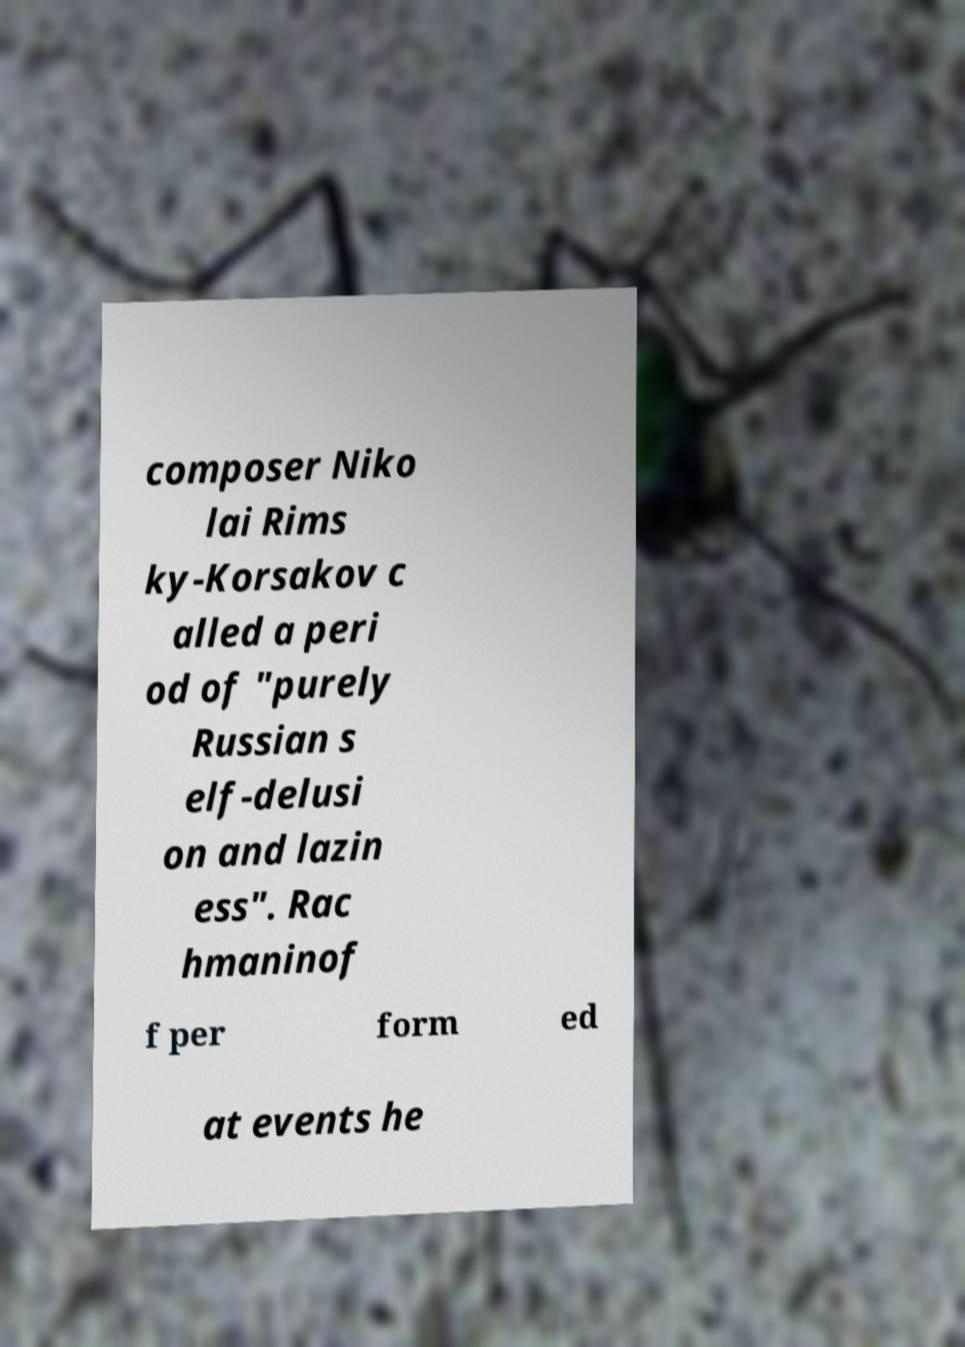For documentation purposes, I need the text within this image transcribed. Could you provide that? composer Niko lai Rims ky-Korsakov c alled a peri od of "purely Russian s elf-delusi on and lazin ess". Rac hmaninof f per form ed at events he 